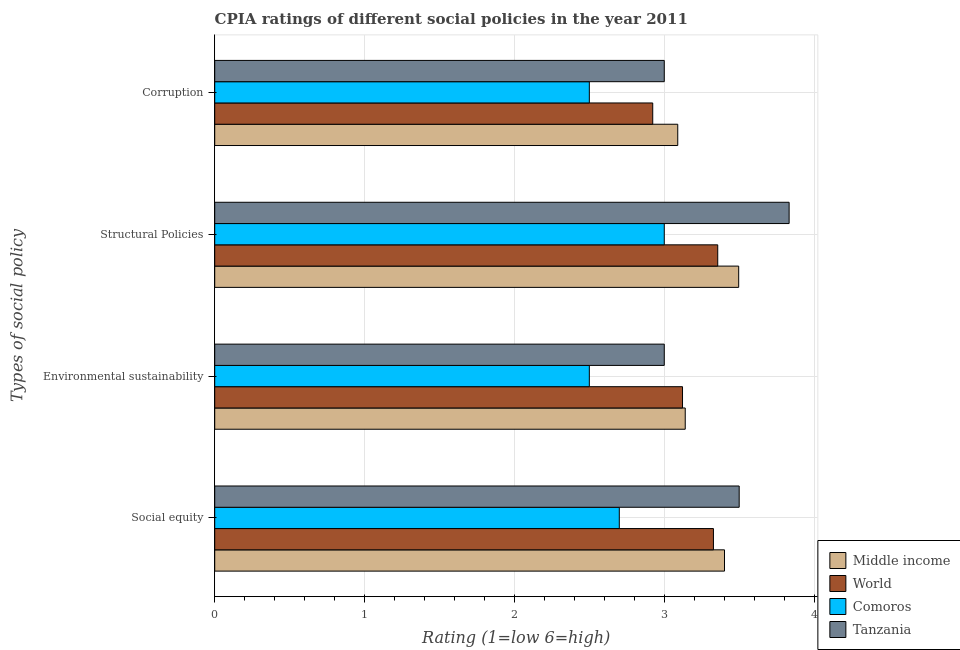How many different coloured bars are there?
Offer a terse response. 4. Are the number of bars per tick equal to the number of legend labels?
Your response must be concise. Yes. Are the number of bars on each tick of the Y-axis equal?
Keep it short and to the point. Yes. How many bars are there on the 2nd tick from the top?
Offer a terse response. 4. What is the label of the 1st group of bars from the top?
Provide a short and direct response. Corruption. What is the cpia rating of environmental sustainability in Comoros?
Give a very brief answer. 2.5. Across all countries, what is the maximum cpia rating of structural policies?
Your answer should be compact. 3.83. Across all countries, what is the minimum cpia rating of social equity?
Your answer should be very brief. 2.7. In which country was the cpia rating of structural policies maximum?
Keep it short and to the point. Tanzania. In which country was the cpia rating of corruption minimum?
Ensure brevity in your answer.  Comoros. What is the total cpia rating of corruption in the graph?
Provide a short and direct response. 11.51. What is the difference between the cpia rating of corruption in Tanzania and that in World?
Offer a terse response. 0.08. What is the difference between the cpia rating of social equity in World and the cpia rating of environmental sustainability in Middle income?
Keep it short and to the point. 0.19. What is the average cpia rating of social equity per country?
Ensure brevity in your answer.  3.23. What is the difference between the cpia rating of corruption and cpia rating of social equity in World?
Offer a terse response. -0.41. What is the ratio of the cpia rating of structural policies in Tanzania to that in Middle income?
Offer a terse response. 1.1. Is the cpia rating of structural policies in Tanzania less than that in Middle income?
Provide a succinct answer. No. Is the difference between the cpia rating of structural policies in Middle income and Comoros greater than the difference between the cpia rating of corruption in Middle income and Comoros?
Ensure brevity in your answer.  No. What is the difference between the highest and the second highest cpia rating of environmental sustainability?
Your response must be concise. 0.02. What is the difference between the highest and the lowest cpia rating of structural policies?
Your answer should be compact. 0.83. In how many countries, is the cpia rating of structural policies greater than the average cpia rating of structural policies taken over all countries?
Your answer should be very brief. 2. Is the sum of the cpia rating of corruption in Comoros and World greater than the maximum cpia rating of environmental sustainability across all countries?
Your answer should be very brief. Yes. Is it the case that in every country, the sum of the cpia rating of social equity and cpia rating of environmental sustainability is greater than the cpia rating of structural policies?
Ensure brevity in your answer.  Yes. How many bars are there?
Keep it short and to the point. 16. What is the difference between two consecutive major ticks on the X-axis?
Give a very brief answer. 1. Are the values on the major ticks of X-axis written in scientific E-notation?
Make the answer very short. No. Where does the legend appear in the graph?
Your answer should be compact. Bottom right. How many legend labels are there?
Make the answer very short. 4. How are the legend labels stacked?
Make the answer very short. Vertical. What is the title of the graph?
Your response must be concise. CPIA ratings of different social policies in the year 2011. What is the label or title of the Y-axis?
Make the answer very short. Types of social policy. What is the Rating (1=low 6=high) in Middle income in Social equity?
Offer a very short reply. 3.4. What is the Rating (1=low 6=high) of World in Social equity?
Keep it short and to the point. 3.33. What is the Rating (1=low 6=high) of Comoros in Social equity?
Offer a terse response. 2.7. What is the Rating (1=low 6=high) of Middle income in Environmental sustainability?
Provide a short and direct response. 3.14. What is the Rating (1=low 6=high) of World in Environmental sustainability?
Your answer should be very brief. 3.12. What is the Rating (1=low 6=high) of Comoros in Environmental sustainability?
Offer a very short reply. 2.5. What is the Rating (1=low 6=high) of Tanzania in Environmental sustainability?
Give a very brief answer. 3. What is the Rating (1=low 6=high) in Middle income in Structural Policies?
Provide a short and direct response. 3.5. What is the Rating (1=low 6=high) in World in Structural Policies?
Offer a terse response. 3.36. What is the Rating (1=low 6=high) of Tanzania in Structural Policies?
Your answer should be compact. 3.83. What is the Rating (1=low 6=high) of Middle income in Corruption?
Make the answer very short. 3.09. What is the Rating (1=low 6=high) of World in Corruption?
Offer a very short reply. 2.92. Across all Types of social policy, what is the maximum Rating (1=low 6=high) of Middle income?
Your answer should be compact. 3.5. Across all Types of social policy, what is the maximum Rating (1=low 6=high) in World?
Provide a succinct answer. 3.36. Across all Types of social policy, what is the maximum Rating (1=low 6=high) of Tanzania?
Keep it short and to the point. 3.83. Across all Types of social policy, what is the minimum Rating (1=low 6=high) of Middle income?
Provide a succinct answer. 3.09. Across all Types of social policy, what is the minimum Rating (1=low 6=high) in World?
Give a very brief answer. 2.92. What is the total Rating (1=low 6=high) in Middle income in the graph?
Offer a terse response. 13.13. What is the total Rating (1=low 6=high) in World in the graph?
Keep it short and to the point. 12.73. What is the total Rating (1=low 6=high) of Comoros in the graph?
Provide a succinct answer. 10.7. What is the total Rating (1=low 6=high) in Tanzania in the graph?
Your answer should be compact. 13.33. What is the difference between the Rating (1=low 6=high) in Middle income in Social equity and that in Environmental sustainability?
Your response must be concise. 0.26. What is the difference between the Rating (1=low 6=high) in World in Social equity and that in Environmental sustainability?
Offer a very short reply. 0.21. What is the difference between the Rating (1=low 6=high) in Tanzania in Social equity and that in Environmental sustainability?
Provide a short and direct response. 0.5. What is the difference between the Rating (1=low 6=high) in Middle income in Social equity and that in Structural Policies?
Your answer should be compact. -0.09. What is the difference between the Rating (1=low 6=high) of World in Social equity and that in Structural Policies?
Your answer should be compact. -0.03. What is the difference between the Rating (1=low 6=high) in Comoros in Social equity and that in Structural Policies?
Your answer should be very brief. -0.3. What is the difference between the Rating (1=low 6=high) of Tanzania in Social equity and that in Structural Policies?
Your answer should be compact. -0.33. What is the difference between the Rating (1=low 6=high) in Middle income in Social equity and that in Corruption?
Your answer should be compact. 0.31. What is the difference between the Rating (1=low 6=high) in World in Social equity and that in Corruption?
Make the answer very short. 0.41. What is the difference between the Rating (1=low 6=high) in Comoros in Social equity and that in Corruption?
Give a very brief answer. 0.2. What is the difference between the Rating (1=low 6=high) of Middle income in Environmental sustainability and that in Structural Policies?
Provide a succinct answer. -0.36. What is the difference between the Rating (1=low 6=high) in World in Environmental sustainability and that in Structural Policies?
Provide a succinct answer. -0.23. What is the difference between the Rating (1=low 6=high) of Tanzania in Environmental sustainability and that in Structural Policies?
Provide a short and direct response. -0.83. What is the difference between the Rating (1=low 6=high) in World in Environmental sustainability and that in Corruption?
Keep it short and to the point. 0.2. What is the difference between the Rating (1=low 6=high) in Middle income in Structural Policies and that in Corruption?
Offer a terse response. 0.41. What is the difference between the Rating (1=low 6=high) of World in Structural Policies and that in Corruption?
Your response must be concise. 0.43. What is the difference between the Rating (1=low 6=high) of Comoros in Structural Policies and that in Corruption?
Offer a very short reply. 0.5. What is the difference between the Rating (1=low 6=high) in Tanzania in Structural Policies and that in Corruption?
Your answer should be compact. 0.83. What is the difference between the Rating (1=low 6=high) in Middle income in Social equity and the Rating (1=low 6=high) in World in Environmental sustainability?
Your answer should be compact. 0.28. What is the difference between the Rating (1=low 6=high) in Middle income in Social equity and the Rating (1=low 6=high) in Comoros in Environmental sustainability?
Your answer should be very brief. 0.9. What is the difference between the Rating (1=low 6=high) in Middle income in Social equity and the Rating (1=low 6=high) in Tanzania in Environmental sustainability?
Your answer should be compact. 0.4. What is the difference between the Rating (1=low 6=high) in World in Social equity and the Rating (1=low 6=high) in Comoros in Environmental sustainability?
Offer a very short reply. 0.83. What is the difference between the Rating (1=low 6=high) of World in Social equity and the Rating (1=low 6=high) of Tanzania in Environmental sustainability?
Make the answer very short. 0.33. What is the difference between the Rating (1=low 6=high) in Middle income in Social equity and the Rating (1=low 6=high) in World in Structural Policies?
Your response must be concise. 0.05. What is the difference between the Rating (1=low 6=high) in Middle income in Social equity and the Rating (1=low 6=high) in Comoros in Structural Policies?
Your response must be concise. 0.4. What is the difference between the Rating (1=low 6=high) of Middle income in Social equity and the Rating (1=low 6=high) of Tanzania in Structural Policies?
Your answer should be compact. -0.43. What is the difference between the Rating (1=low 6=high) of World in Social equity and the Rating (1=low 6=high) of Comoros in Structural Policies?
Make the answer very short. 0.33. What is the difference between the Rating (1=low 6=high) of World in Social equity and the Rating (1=low 6=high) of Tanzania in Structural Policies?
Your answer should be compact. -0.51. What is the difference between the Rating (1=low 6=high) in Comoros in Social equity and the Rating (1=low 6=high) in Tanzania in Structural Policies?
Ensure brevity in your answer.  -1.13. What is the difference between the Rating (1=low 6=high) in Middle income in Social equity and the Rating (1=low 6=high) in World in Corruption?
Keep it short and to the point. 0.48. What is the difference between the Rating (1=low 6=high) of Middle income in Social equity and the Rating (1=low 6=high) of Comoros in Corruption?
Your answer should be compact. 0.9. What is the difference between the Rating (1=low 6=high) of Middle income in Social equity and the Rating (1=low 6=high) of Tanzania in Corruption?
Ensure brevity in your answer.  0.4. What is the difference between the Rating (1=low 6=high) of World in Social equity and the Rating (1=low 6=high) of Comoros in Corruption?
Provide a succinct answer. 0.83. What is the difference between the Rating (1=low 6=high) in World in Social equity and the Rating (1=low 6=high) in Tanzania in Corruption?
Ensure brevity in your answer.  0.33. What is the difference between the Rating (1=low 6=high) of Comoros in Social equity and the Rating (1=low 6=high) of Tanzania in Corruption?
Provide a succinct answer. -0.3. What is the difference between the Rating (1=low 6=high) in Middle income in Environmental sustainability and the Rating (1=low 6=high) in World in Structural Policies?
Provide a short and direct response. -0.22. What is the difference between the Rating (1=low 6=high) in Middle income in Environmental sustainability and the Rating (1=low 6=high) in Comoros in Structural Policies?
Your answer should be very brief. 0.14. What is the difference between the Rating (1=low 6=high) in Middle income in Environmental sustainability and the Rating (1=low 6=high) in Tanzania in Structural Policies?
Keep it short and to the point. -0.69. What is the difference between the Rating (1=low 6=high) of World in Environmental sustainability and the Rating (1=low 6=high) of Comoros in Structural Policies?
Offer a very short reply. 0.12. What is the difference between the Rating (1=low 6=high) in World in Environmental sustainability and the Rating (1=low 6=high) in Tanzania in Structural Policies?
Give a very brief answer. -0.71. What is the difference between the Rating (1=low 6=high) of Comoros in Environmental sustainability and the Rating (1=low 6=high) of Tanzania in Structural Policies?
Provide a short and direct response. -1.33. What is the difference between the Rating (1=low 6=high) of Middle income in Environmental sustainability and the Rating (1=low 6=high) of World in Corruption?
Keep it short and to the point. 0.22. What is the difference between the Rating (1=low 6=high) of Middle income in Environmental sustainability and the Rating (1=low 6=high) of Comoros in Corruption?
Provide a short and direct response. 0.64. What is the difference between the Rating (1=low 6=high) in Middle income in Environmental sustainability and the Rating (1=low 6=high) in Tanzania in Corruption?
Your response must be concise. 0.14. What is the difference between the Rating (1=low 6=high) of World in Environmental sustainability and the Rating (1=low 6=high) of Comoros in Corruption?
Make the answer very short. 0.62. What is the difference between the Rating (1=low 6=high) in World in Environmental sustainability and the Rating (1=low 6=high) in Tanzania in Corruption?
Ensure brevity in your answer.  0.12. What is the difference between the Rating (1=low 6=high) in Middle income in Structural Policies and the Rating (1=low 6=high) in World in Corruption?
Ensure brevity in your answer.  0.57. What is the difference between the Rating (1=low 6=high) in Middle income in Structural Policies and the Rating (1=low 6=high) in Comoros in Corruption?
Your response must be concise. 1. What is the difference between the Rating (1=low 6=high) of Middle income in Structural Policies and the Rating (1=low 6=high) of Tanzania in Corruption?
Provide a succinct answer. 0.5. What is the difference between the Rating (1=low 6=high) of World in Structural Policies and the Rating (1=low 6=high) of Comoros in Corruption?
Your response must be concise. 0.86. What is the difference between the Rating (1=low 6=high) of World in Structural Policies and the Rating (1=low 6=high) of Tanzania in Corruption?
Offer a terse response. 0.36. What is the average Rating (1=low 6=high) of Middle income per Types of social policy?
Give a very brief answer. 3.28. What is the average Rating (1=low 6=high) of World per Types of social policy?
Provide a short and direct response. 3.18. What is the average Rating (1=low 6=high) in Comoros per Types of social policy?
Provide a short and direct response. 2.67. What is the difference between the Rating (1=low 6=high) of Middle income and Rating (1=low 6=high) of World in Social equity?
Your answer should be compact. 0.07. What is the difference between the Rating (1=low 6=high) in Middle income and Rating (1=low 6=high) in Comoros in Social equity?
Make the answer very short. 0.7. What is the difference between the Rating (1=low 6=high) in Middle income and Rating (1=low 6=high) in Tanzania in Social equity?
Keep it short and to the point. -0.1. What is the difference between the Rating (1=low 6=high) of World and Rating (1=low 6=high) of Comoros in Social equity?
Your answer should be compact. 0.63. What is the difference between the Rating (1=low 6=high) in World and Rating (1=low 6=high) in Tanzania in Social equity?
Ensure brevity in your answer.  -0.17. What is the difference between the Rating (1=low 6=high) of Comoros and Rating (1=low 6=high) of Tanzania in Social equity?
Give a very brief answer. -0.8. What is the difference between the Rating (1=low 6=high) in Middle income and Rating (1=low 6=high) in World in Environmental sustainability?
Provide a succinct answer. 0.02. What is the difference between the Rating (1=low 6=high) in Middle income and Rating (1=low 6=high) in Comoros in Environmental sustainability?
Offer a terse response. 0.64. What is the difference between the Rating (1=low 6=high) of Middle income and Rating (1=low 6=high) of Tanzania in Environmental sustainability?
Make the answer very short. 0.14. What is the difference between the Rating (1=low 6=high) of World and Rating (1=low 6=high) of Comoros in Environmental sustainability?
Make the answer very short. 0.62. What is the difference between the Rating (1=low 6=high) in World and Rating (1=low 6=high) in Tanzania in Environmental sustainability?
Provide a succinct answer. 0.12. What is the difference between the Rating (1=low 6=high) in Comoros and Rating (1=low 6=high) in Tanzania in Environmental sustainability?
Make the answer very short. -0.5. What is the difference between the Rating (1=low 6=high) in Middle income and Rating (1=low 6=high) in World in Structural Policies?
Offer a terse response. 0.14. What is the difference between the Rating (1=low 6=high) of Middle income and Rating (1=low 6=high) of Comoros in Structural Policies?
Give a very brief answer. 0.5. What is the difference between the Rating (1=low 6=high) in Middle income and Rating (1=low 6=high) in Tanzania in Structural Policies?
Make the answer very short. -0.34. What is the difference between the Rating (1=low 6=high) in World and Rating (1=low 6=high) in Comoros in Structural Policies?
Make the answer very short. 0.36. What is the difference between the Rating (1=low 6=high) in World and Rating (1=low 6=high) in Tanzania in Structural Policies?
Your answer should be compact. -0.48. What is the difference between the Rating (1=low 6=high) of Comoros and Rating (1=low 6=high) of Tanzania in Structural Policies?
Provide a succinct answer. -0.83. What is the difference between the Rating (1=low 6=high) in Middle income and Rating (1=low 6=high) in World in Corruption?
Offer a terse response. 0.17. What is the difference between the Rating (1=low 6=high) of Middle income and Rating (1=low 6=high) of Comoros in Corruption?
Offer a very short reply. 0.59. What is the difference between the Rating (1=low 6=high) of Middle income and Rating (1=low 6=high) of Tanzania in Corruption?
Offer a terse response. 0.09. What is the difference between the Rating (1=low 6=high) of World and Rating (1=low 6=high) of Comoros in Corruption?
Provide a short and direct response. 0.42. What is the difference between the Rating (1=low 6=high) of World and Rating (1=low 6=high) of Tanzania in Corruption?
Your response must be concise. -0.08. What is the difference between the Rating (1=low 6=high) of Comoros and Rating (1=low 6=high) of Tanzania in Corruption?
Your answer should be very brief. -0.5. What is the ratio of the Rating (1=low 6=high) in Middle income in Social equity to that in Environmental sustainability?
Ensure brevity in your answer.  1.08. What is the ratio of the Rating (1=low 6=high) of World in Social equity to that in Environmental sustainability?
Offer a very short reply. 1.07. What is the ratio of the Rating (1=low 6=high) in Tanzania in Social equity to that in Environmental sustainability?
Provide a succinct answer. 1.17. What is the ratio of the Rating (1=low 6=high) in Middle income in Social equity to that in Structural Policies?
Offer a terse response. 0.97. What is the ratio of the Rating (1=low 6=high) of World in Social equity to that in Structural Policies?
Offer a very short reply. 0.99. What is the ratio of the Rating (1=low 6=high) in Comoros in Social equity to that in Structural Policies?
Your response must be concise. 0.9. What is the ratio of the Rating (1=low 6=high) in Middle income in Social equity to that in Corruption?
Offer a very short reply. 1.1. What is the ratio of the Rating (1=low 6=high) of World in Social equity to that in Corruption?
Your answer should be compact. 1.14. What is the ratio of the Rating (1=low 6=high) in Comoros in Social equity to that in Corruption?
Offer a terse response. 1.08. What is the ratio of the Rating (1=low 6=high) of Middle income in Environmental sustainability to that in Structural Policies?
Give a very brief answer. 0.9. What is the ratio of the Rating (1=low 6=high) in Comoros in Environmental sustainability to that in Structural Policies?
Keep it short and to the point. 0.83. What is the ratio of the Rating (1=low 6=high) in Tanzania in Environmental sustainability to that in Structural Policies?
Offer a very short reply. 0.78. What is the ratio of the Rating (1=low 6=high) in Middle income in Environmental sustainability to that in Corruption?
Provide a short and direct response. 1.02. What is the ratio of the Rating (1=low 6=high) of World in Environmental sustainability to that in Corruption?
Provide a short and direct response. 1.07. What is the ratio of the Rating (1=low 6=high) in Middle income in Structural Policies to that in Corruption?
Keep it short and to the point. 1.13. What is the ratio of the Rating (1=low 6=high) in World in Structural Policies to that in Corruption?
Your answer should be very brief. 1.15. What is the ratio of the Rating (1=low 6=high) of Tanzania in Structural Policies to that in Corruption?
Keep it short and to the point. 1.28. What is the difference between the highest and the second highest Rating (1=low 6=high) of Middle income?
Make the answer very short. 0.09. What is the difference between the highest and the second highest Rating (1=low 6=high) in World?
Offer a terse response. 0.03. What is the difference between the highest and the lowest Rating (1=low 6=high) in Middle income?
Keep it short and to the point. 0.41. What is the difference between the highest and the lowest Rating (1=low 6=high) of World?
Provide a short and direct response. 0.43. What is the difference between the highest and the lowest Rating (1=low 6=high) in Comoros?
Your response must be concise. 0.5. What is the difference between the highest and the lowest Rating (1=low 6=high) of Tanzania?
Your response must be concise. 0.83. 